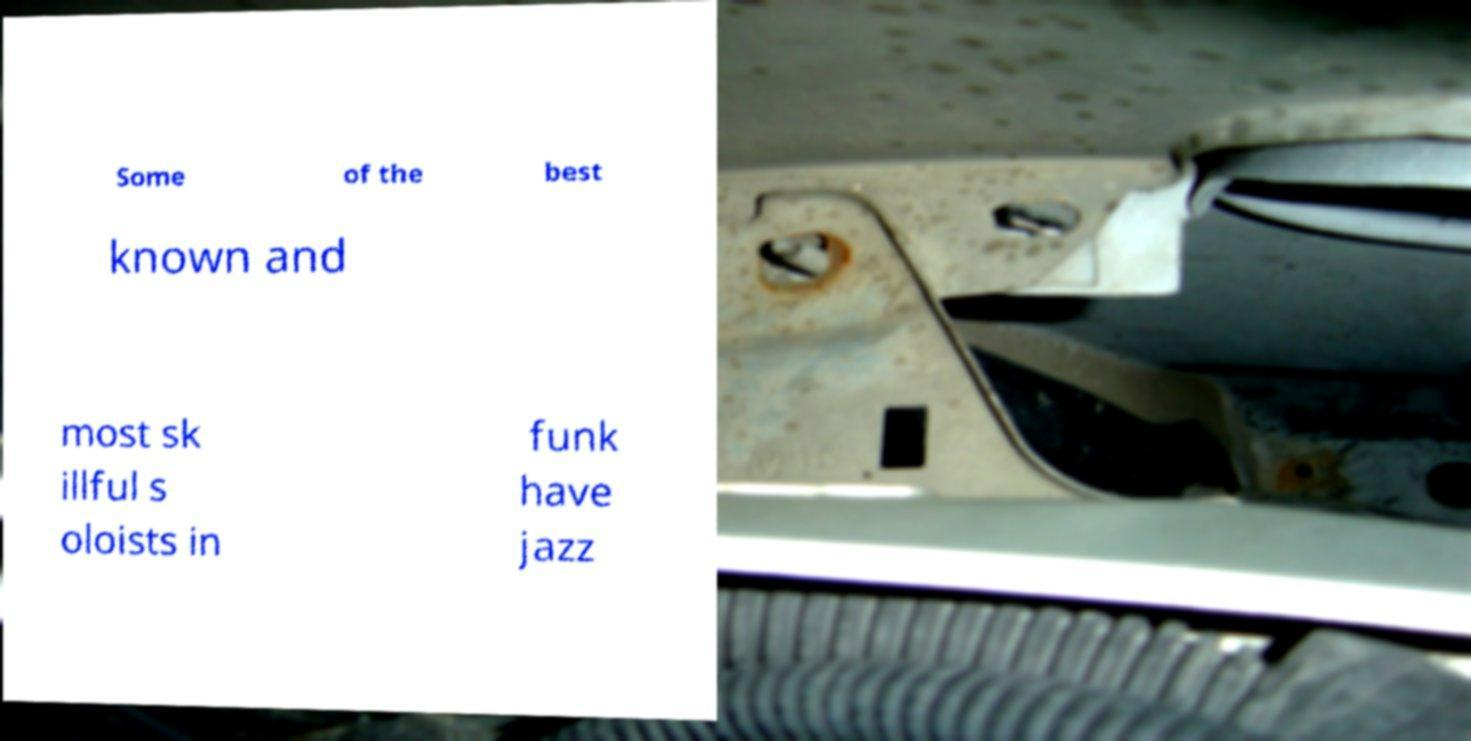I need the written content from this picture converted into text. Can you do that? Some of the best known and most sk illful s oloists in funk have jazz 